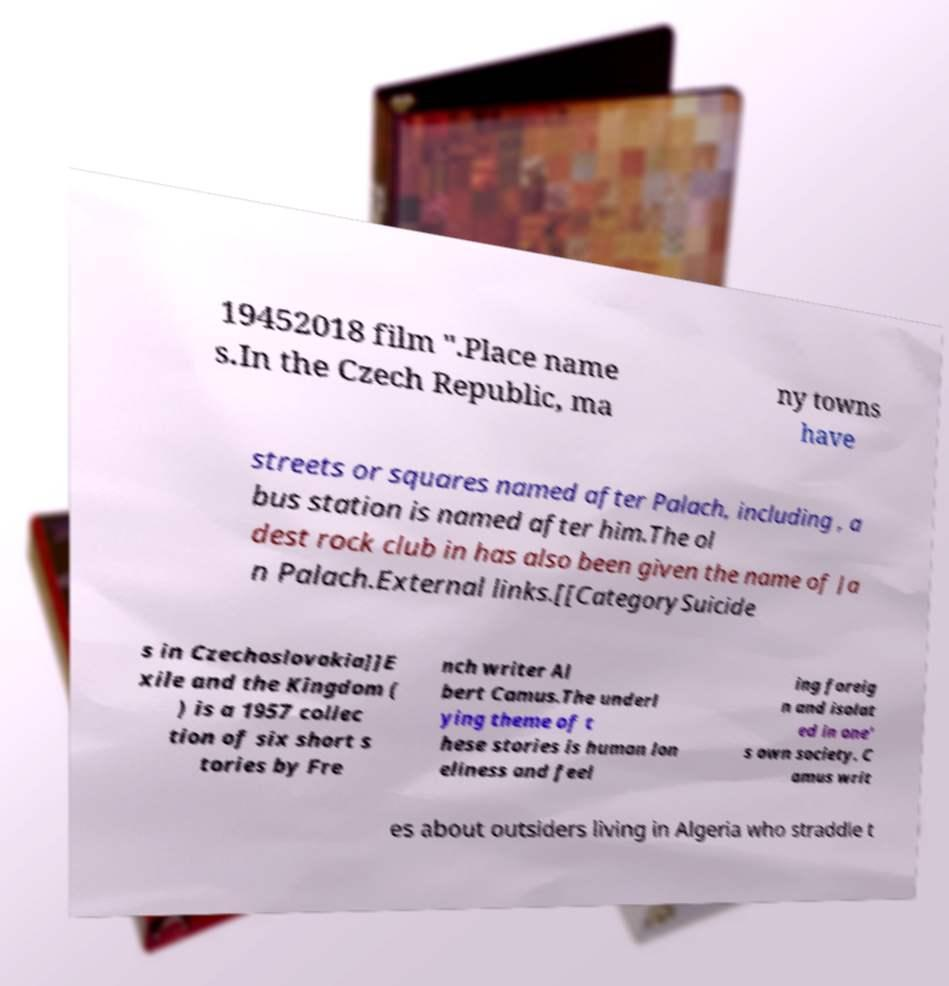Can you accurately transcribe the text from the provided image for me? 19452018 film ".Place name s.In the Czech Republic, ma ny towns have streets or squares named after Palach, including , a bus station is named after him.The ol dest rock club in has also been given the name of Ja n Palach.External links.[[CategorySuicide s in Czechoslovakia]]E xile and the Kingdom ( ) is a 1957 collec tion of six short s tories by Fre nch writer Al bert Camus.The underl ying theme of t hese stories is human lon eliness and feel ing foreig n and isolat ed in one' s own society. C amus writ es about outsiders living in Algeria who straddle t 